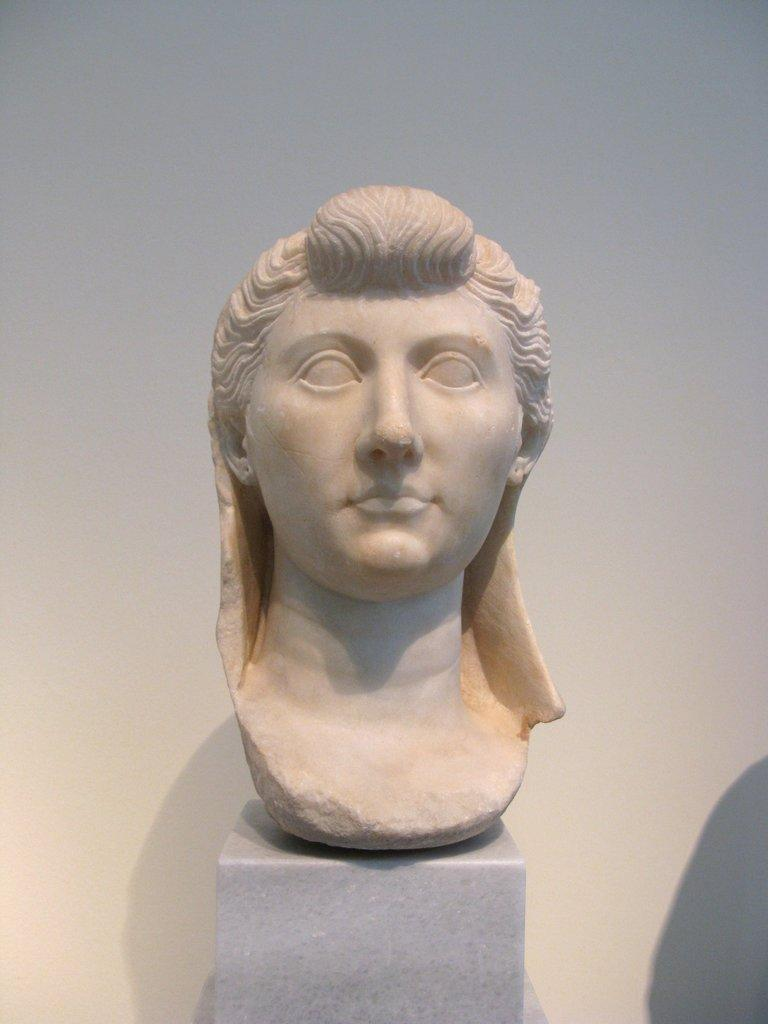What is the main subject of the image? There is a sculpture of a person's head in the image. What can be seen behind the sculpture? There is a wall behind the sculpture. How many chickens are sitting on the basketball player's trousers in the image? There are no chickens or basketball players present in the image; it features a sculpture of a person's head and a wall. 